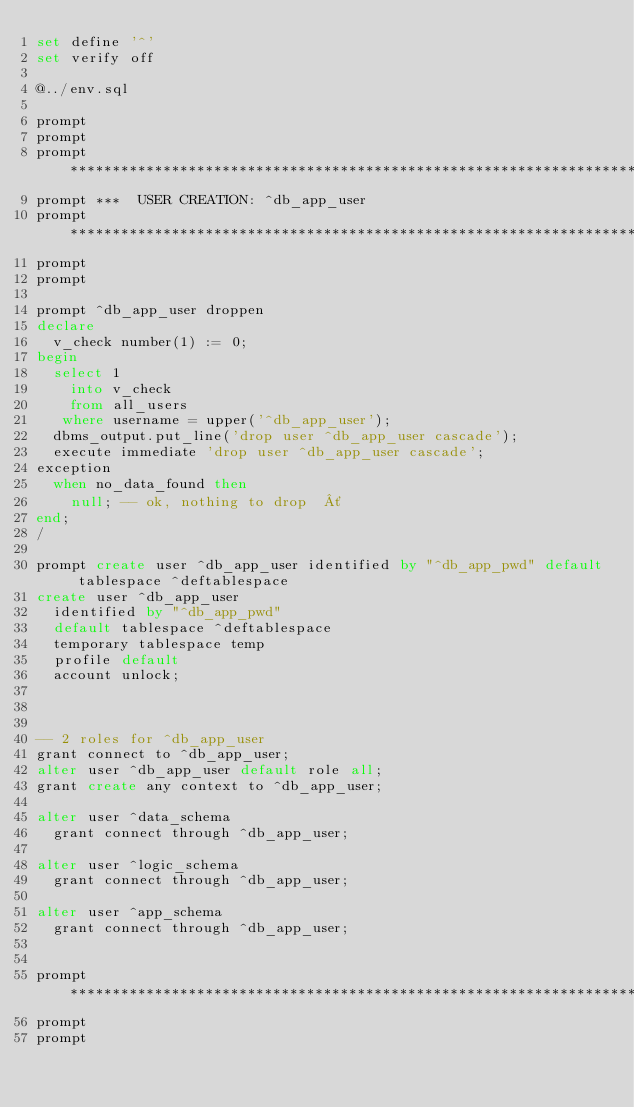<code> <loc_0><loc_0><loc_500><loc_500><_SQL_>set define '^'
set verify off

@../env.sql

prompt
prompt
prompt **********************************************************************
prompt ***  USER CREATION: ^db_app_user
prompt **********************************************************************
prompt
prompt

prompt ^db_app_user droppen
declare
  v_check number(1) := 0;
begin
  select 1
    into v_check
    from all_users
   where username = upper('^db_app_user');
  dbms_output.put_line('drop user ^db_app_user cascade');
  execute immediate 'drop user ^db_app_user cascade';
exception
  when no_data_found then
    null; -- ok, nothing to drop  ´
end;
/

prompt create user ^db_app_user identified by "^db_app_pwd" default tablespace ^deftablespace
create user ^db_app_user
  identified by "^db_app_pwd"
  default tablespace ^deftablespace
  temporary tablespace temp
  profile default
  account unlock;



-- 2 roles for ^db_app_user
grant connect to ^db_app_user;
alter user ^db_app_user default role all;
grant create any context to ^db_app_user;

alter user ^data_schema
  grant connect through ^db_app_user;

alter user ^logic_schema
  grant connect through ^db_app_user;

alter user ^app_schema
  grant connect through ^db_app_user;


prompt **********************************************************************
prompt
prompt</code> 